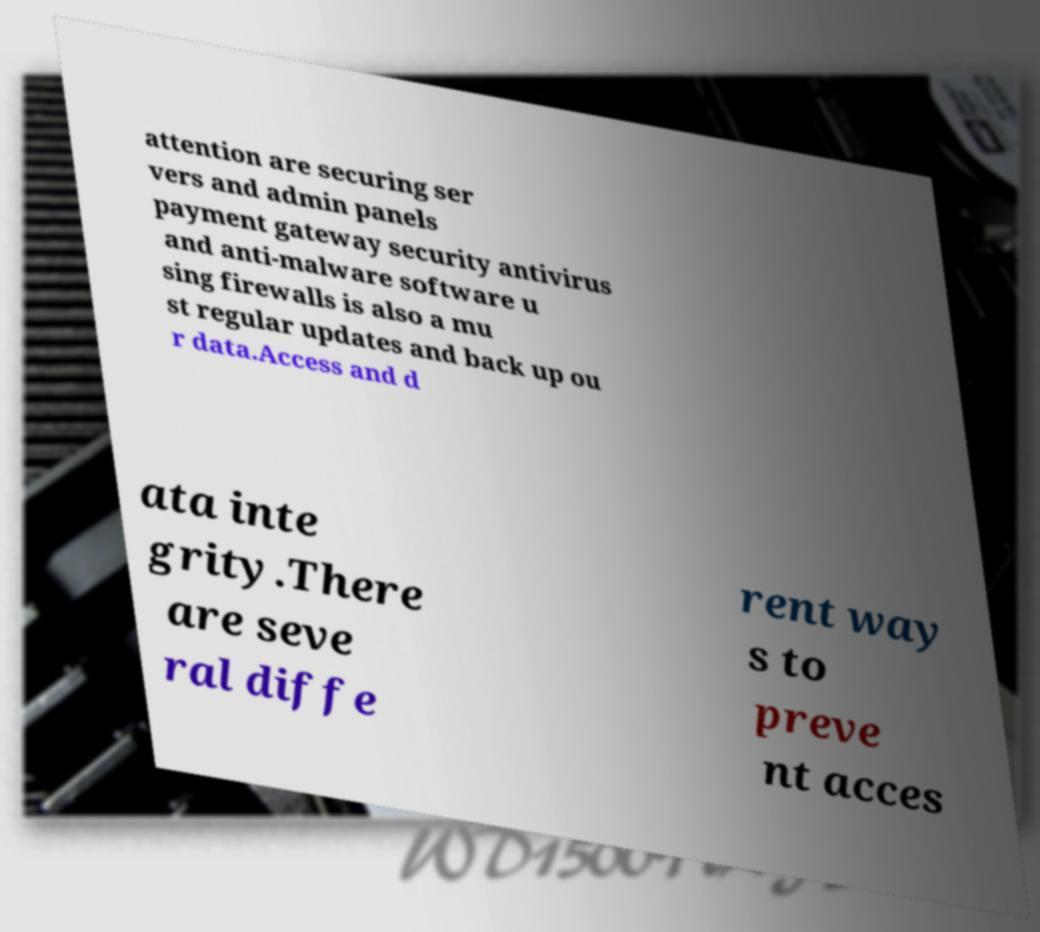For documentation purposes, I need the text within this image transcribed. Could you provide that? attention are securing ser vers and admin panels payment gateway security antivirus and anti-malware software u sing firewalls is also a mu st regular updates and back up ou r data.Access and d ata inte grity.There are seve ral diffe rent way s to preve nt acces 